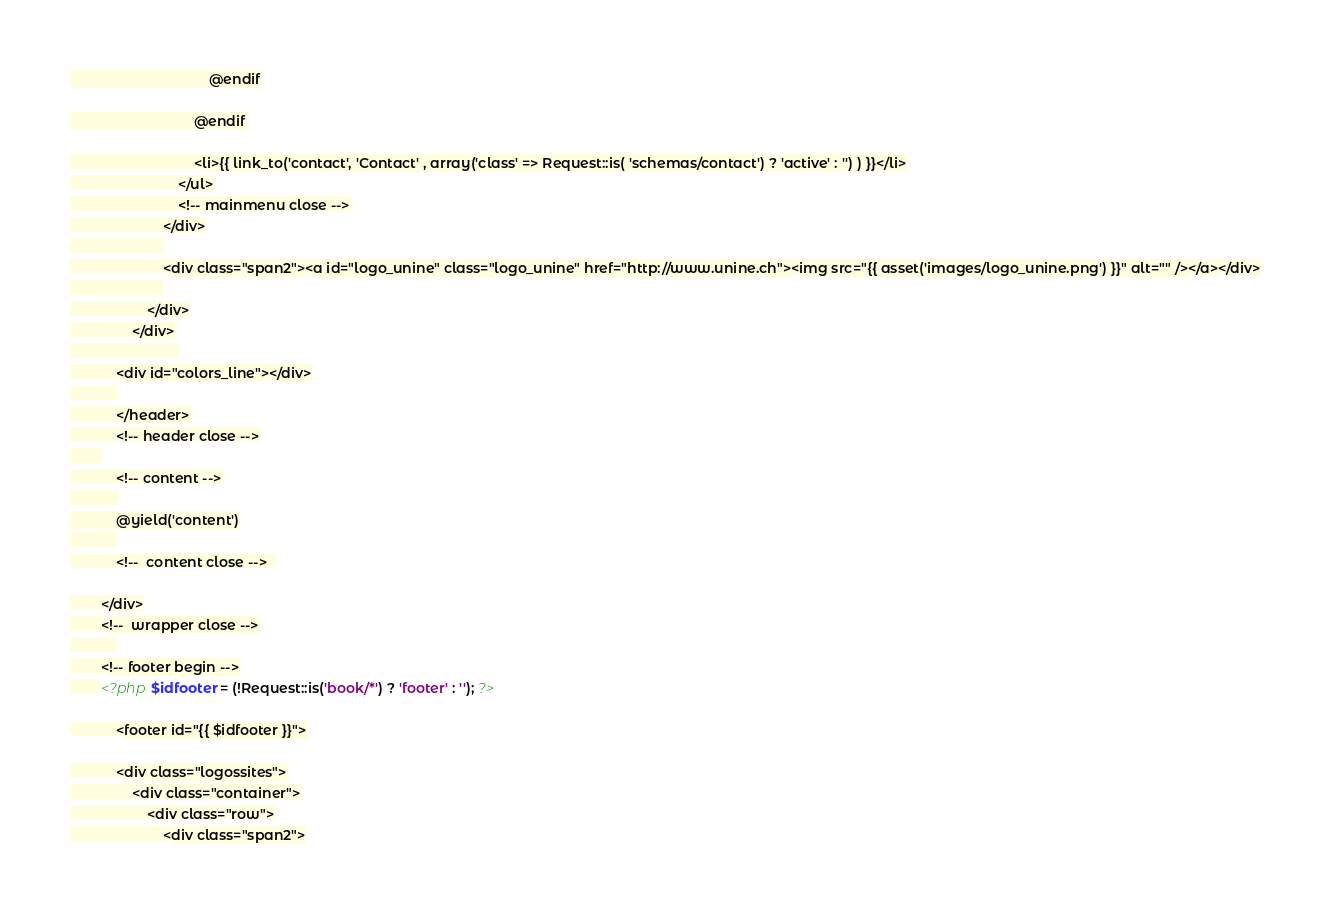<code> <loc_0><loc_0><loc_500><loc_500><_PHP_>                                    @endif

                                @endif

			                    <li>{{ link_to('contact', 'Contact' , array('class' => Request::is( 'schemas/contact') ? 'active' : '') ) }}</li>
			                </ul>
			                <!-- mainmenu close -->
						</div>
						
						<div class="span2"><a id="logo_unine" class="logo_unine" href="http://www.unine.ch"><img src="{{ asset('images/logo_unine.png') }}" alt="" /></a></div>
						
	            	</div>
	            </div>
	            	        
	        <div id="colors_line"></div>
	        
	        </header>
	        <!-- header close -->
        
	        <!-- content -->
	        
	        @yield('content')
	        
	        <!--  content close -->  

		</div>
		<!--  wrapper close -->
            
        <!-- footer begin -->
        <?php $idfooter = (!Request::is('book/*') ? 'footer' : ''); ?>

            <footer id="{{ $idfooter }}">

            <div class="logossites">
                <div class="container">
                    <div class="row">
                        <div class="span2"></code> 